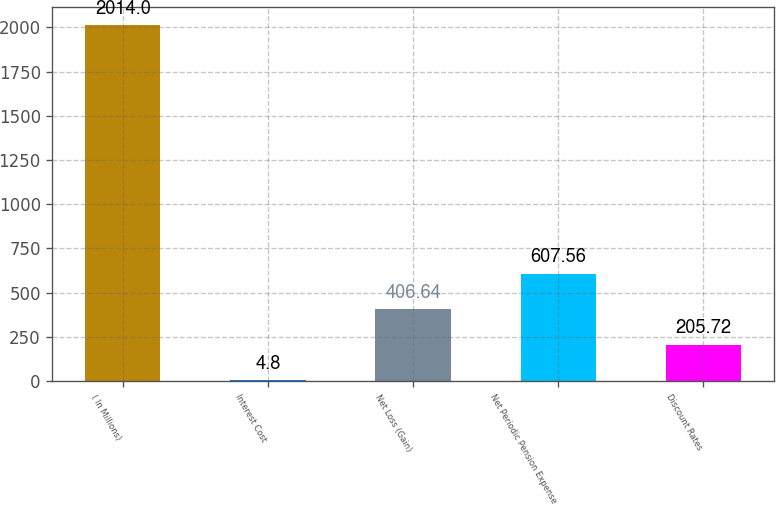<chart> <loc_0><loc_0><loc_500><loc_500><bar_chart><fcel>( In Millions)<fcel>Interest Cost<fcel>Net Loss (Gain)<fcel>Net Periodic Pension Expense<fcel>Discount Rates<nl><fcel>2014<fcel>4.8<fcel>406.64<fcel>607.56<fcel>205.72<nl></chart> 